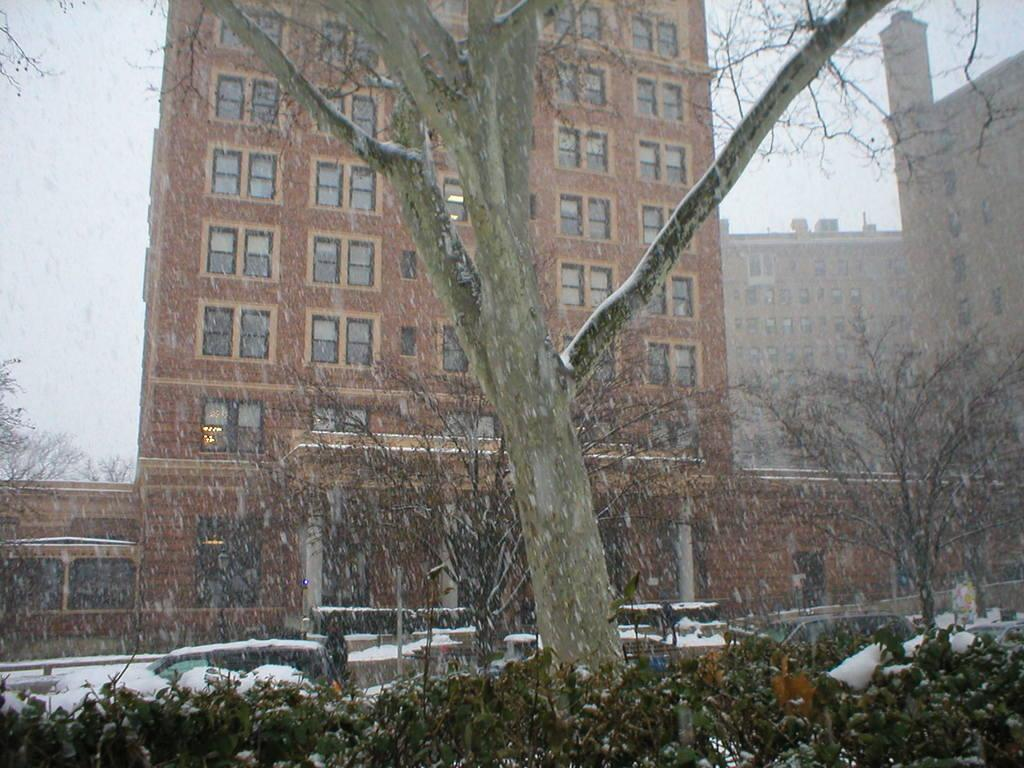What type of vegetation can be seen in the image? There are dried trees in the image. What else can be seen in the background of the image? Vehicles covered with snow and a brown-colored building are visible in the background. How would you describe the color of the sky in the image? The sky appears to be white in color. Who is preparing the meal in the image? There is no meal preparation or person cooking in the image. 